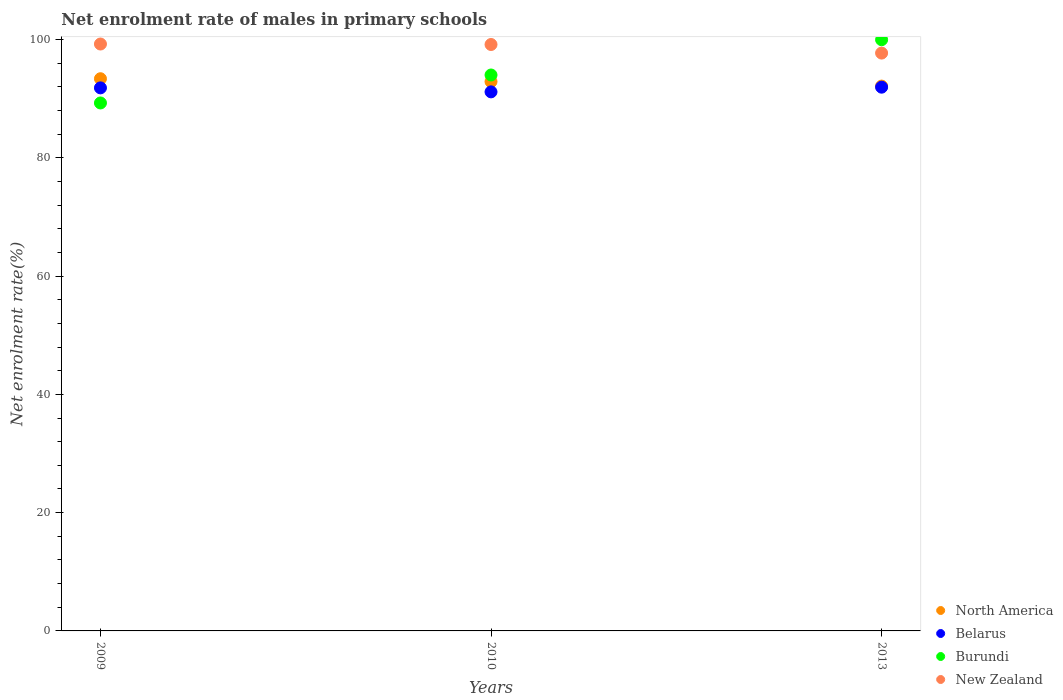How many different coloured dotlines are there?
Make the answer very short. 4. Is the number of dotlines equal to the number of legend labels?
Offer a terse response. Yes. What is the net enrolment rate of males in primary schools in North America in 2013?
Provide a short and direct response. 92.12. Across all years, what is the maximum net enrolment rate of males in primary schools in North America?
Make the answer very short. 93.36. Across all years, what is the minimum net enrolment rate of males in primary schools in Burundi?
Offer a terse response. 89.27. In which year was the net enrolment rate of males in primary schools in North America maximum?
Provide a succinct answer. 2009. In which year was the net enrolment rate of males in primary schools in New Zealand minimum?
Provide a short and direct response. 2013. What is the total net enrolment rate of males in primary schools in New Zealand in the graph?
Offer a terse response. 296.08. What is the difference between the net enrolment rate of males in primary schools in New Zealand in 2009 and that in 2010?
Provide a succinct answer. 0.08. What is the difference between the net enrolment rate of males in primary schools in Burundi in 2013 and the net enrolment rate of males in primary schools in New Zealand in 2010?
Offer a terse response. 0.81. What is the average net enrolment rate of males in primary schools in North America per year?
Provide a succinct answer. 92.78. In the year 2009, what is the difference between the net enrolment rate of males in primary schools in North America and net enrolment rate of males in primary schools in New Zealand?
Your response must be concise. -5.87. In how many years, is the net enrolment rate of males in primary schools in New Zealand greater than 56 %?
Offer a terse response. 3. What is the ratio of the net enrolment rate of males in primary schools in North America in 2009 to that in 2013?
Provide a succinct answer. 1.01. Is the net enrolment rate of males in primary schools in New Zealand in 2009 less than that in 2010?
Provide a short and direct response. No. Is the difference between the net enrolment rate of males in primary schools in North America in 2009 and 2013 greater than the difference between the net enrolment rate of males in primary schools in New Zealand in 2009 and 2013?
Offer a terse response. No. What is the difference between the highest and the second highest net enrolment rate of males in primary schools in North America?
Your response must be concise. 0.49. What is the difference between the highest and the lowest net enrolment rate of males in primary schools in Burundi?
Make the answer very short. 10.69. In how many years, is the net enrolment rate of males in primary schools in Belarus greater than the average net enrolment rate of males in primary schools in Belarus taken over all years?
Make the answer very short. 2. Is it the case that in every year, the sum of the net enrolment rate of males in primary schools in Burundi and net enrolment rate of males in primary schools in North America  is greater than the sum of net enrolment rate of males in primary schools in Belarus and net enrolment rate of males in primary schools in New Zealand?
Your answer should be very brief. No. Is it the case that in every year, the sum of the net enrolment rate of males in primary schools in Burundi and net enrolment rate of males in primary schools in Belarus  is greater than the net enrolment rate of males in primary schools in New Zealand?
Your response must be concise. Yes. How many dotlines are there?
Keep it short and to the point. 4. How many years are there in the graph?
Make the answer very short. 3. What is the difference between two consecutive major ticks on the Y-axis?
Your response must be concise. 20. Does the graph contain any zero values?
Offer a terse response. No. Does the graph contain grids?
Your answer should be compact. No. How many legend labels are there?
Keep it short and to the point. 4. What is the title of the graph?
Keep it short and to the point. Net enrolment rate of males in primary schools. What is the label or title of the Y-axis?
Offer a very short reply. Net enrolment rate(%). What is the Net enrolment rate(%) in North America in 2009?
Offer a terse response. 93.36. What is the Net enrolment rate(%) of Belarus in 2009?
Provide a succinct answer. 91.82. What is the Net enrolment rate(%) in Burundi in 2009?
Keep it short and to the point. 89.27. What is the Net enrolment rate(%) of New Zealand in 2009?
Ensure brevity in your answer.  99.23. What is the Net enrolment rate(%) of North America in 2010?
Your answer should be very brief. 92.87. What is the Net enrolment rate(%) of Belarus in 2010?
Ensure brevity in your answer.  91.14. What is the Net enrolment rate(%) in Burundi in 2010?
Offer a terse response. 93.99. What is the Net enrolment rate(%) in New Zealand in 2010?
Your answer should be compact. 99.15. What is the Net enrolment rate(%) of North America in 2013?
Your response must be concise. 92.12. What is the Net enrolment rate(%) of Belarus in 2013?
Your answer should be very brief. 91.93. What is the Net enrolment rate(%) in Burundi in 2013?
Your response must be concise. 99.96. What is the Net enrolment rate(%) of New Zealand in 2013?
Your answer should be compact. 97.7. Across all years, what is the maximum Net enrolment rate(%) of North America?
Make the answer very short. 93.36. Across all years, what is the maximum Net enrolment rate(%) of Belarus?
Ensure brevity in your answer.  91.93. Across all years, what is the maximum Net enrolment rate(%) of Burundi?
Provide a short and direct response. 99.96. Across all years, what is the maximum Net enrolment rate(%) of New Zealand?
Make the answer very short. 99.23. Across all years, what is the minimum Net enrolment rate(%) in North America?
Provide a short and direct response. 92.12. Across all years, what is the minimum Net enrolment rate(%) of Belarus?
Offer a terse response. 91.14. Across all years, what is the minimum Net enrolment rate(%) in Burundi?
Provide a succinct answer. 89.27. Across all years, what is the minimum Net enrolment rate(%) of New Zealand?
Provide a succinct answer. 97.7. What is the total Net enrolment rate(%) of North America in the graph?
Give a very brief answer. 278.35. What is the total Net enrolment rate(%) of Belarus in the graph?
Offer a terse response. 274.89. What is the total Net enrolment rate(%) in Burundi in the graph?
Offer a very short reply. 283.22. What is the total Net enrolment rate(%) of New Zealand in the graph?
Offer a very short reply. 296.08. What is the difference between the Net enrolment rate(%) in North America in 2009 and that in 2010?
Give a very brief answer. 0.49. What is the difference between the Net enrolment rate(%) of Belarus in 2009 and that in 2010?
Keep it short and to the point. 0.68. What is the difference between the Net enrolment rate(%) in Burundi in 2009 and that in 2010?
Offer a very short reply. -4.73. What is the difference between the Net enrolment rate(%) in New Zealand in 2009 and that in 2010?
Offer a terse response. 0.08. What is the difference between the Net enrolment rate(%) in North America in 2009 and that in 2013?
Your answer should be compact. 1.25. What is the difference between the Net enrolment rate(%) in Belarus in 2009 and that in 2013?
Ensure brevity in your answer.  -0.12. What is the difference between the Net enrolment rate(%) of Burundi in 2009 and that in 2013?
Your answer should be very brief. -10.69. What is the difference between the Net enrolment rate(%) in New Zealand in 2009 and that in 2013?
Your response must be concise. 1.53. What is the difference between the Net enrolment rate(%) of North America in 2010 and that in 2013?
Keep it short and to the point. 0.76. What is the difference between the Net enrolment rate(%) in Belarus in 2010 and that in 2013?
Your response must be concise. -0.79. What is the difference between the Net enrolment rate(%) of Burundi in 2010 and that in 2013?
Your answer should be compact. -5.96. What is the difference between the Net enrolment rate(%) in New Zealand in 2010 and that in 2013?
Make the answer very short. 1.45. What is the difference between the Net enrolment rate(%) of North America in 2009 and the Net enrolment rate(%) of Belarus in 2010?
Provide a short and direct response. 2.22. What is the difference between the Net enrolment rate(%) in North America in 2009 and the Net enrolment rate(%) in Burundi in 2010?
Your answer should be very brief. -0.63. What is the difference between the Net enrolment rate(%) of North America in 2009 and the Net enrolment rate(%) of New Zealand in 2010?
Your response must be concise. -5.79. What is the difference between the Net enrolment rate(%) in Belarus in 2009 and the Net enrolment rate(%) in Burundi in 2010?
Your answer should be compact. -2.18. What is the difference between the Net enrolment rate(%) of Belarus in 2009 and the Net enrolment rate(%) of New Zealand in 2010?
Your answer should be compact. -7.33. What is the difference between the Net enrolment rate(%) of Burundi in 2009 and the Net enrolment rate(%) of New Zealand in 2010?
Provide a succinct answer. -9.88. What is the difference between the Net enrolment rate(%) in North America in 2009 and the Net enrolment rate(%) in Belarus in 2013?
Make the answer very short. 1.43. What is the difference between the Net enrolment rate(%) in North America in 2009 and the Net enrolment rate(%) in Burundi in 2013?
Make the answer very short. -6.59. What is the difference between the Net enrolment rate(%) of North America in 2009 and the Net enrolment rate(%) of New Zealand in 2013?
Provide a short and direct response. -4.34. What is the difference between the Net enrolment rate(%) of Belarus in 2009 and the Net enrolment rate(%) of Burundi in 2013?
Your answer should be very brief. -8.14. What is the difference between the Net enrolment rate(%) in Belarus in 2009 and the Net enrolment rate(%) in New Zealand in 2013?
Keep it short and to the point. -5.88. What is the difference between the Net enrolment rate(%) in Burundi in 2009 and the Net enrolment rate(%) in New Zealand in 2013?
Provide a succinct answer. -8.43. What is the difference between the Net enrolment rate(%) in North America in 2010 and the Net enrolment rate(%) in Belarus in 2013?
Provide a short and direct response. 0.94. What is the difference between the Net enrolment rate(%) of North America in 2010 and the Net enrolment rate(%) of Burundi in 2013?
Ensure brevity in your answer.  -7.08. What is the difference between the Net enrolment rate(%) in North America in 2010 and the Net enrolment rate(%) in New Zealand in 2013?
Your answer should be very brief. -4.83. What is the difference between the Net enrolment rate(%) of Belarus in 2010 and the Net enrolment rate(%) of Burundi in 2013?
Provide a succinct answer. -8.81. What is the difference between the Net enrolment rate(%) of Belarus in 2010 and the Net enrolment rate(%) of New Zealand in 2013?
Your answer should be compact. -6.56. What is the difference between the Net enrolment rate(%) of Burundi in 2010 and the Net enrolment rate(%) of New Zealand in 2013?
Your answer should be very brief. -3.71. What is the average Net enrolment rate(%) in North America per year?
Make the answer very short. 92.78. What is the average Net enrolment rate(%) of Belarus per year?
Your answer should be very brief. 91.63. What is the average Net enrolment rate(%) of Burundi per year?
Keep it short and to the point. 94.41. What is the average Net enrolment rate(%) in New Zealand per year?
Your answer should be compact. 98.69. In the year 2009, what is the difference between the Net enrolment rate(%) of North America and Net enrolment rate(%) of Belarus?
Provide a short and direct response. 1.55. In the year 2009, what is the difference between the Net enrolment rate(%) of North America and Net enrolment rate(%) of Burundi?
Ensure brevity in your answer.  4.1. In the year 2009, what is the difference between the Net enrolment rate(%) in North America and Net enrolment rate(%) in New Zealand?
Give a very brief answer. -5.87. In the year 2009, what is the difference between the Net enrolment rate(%) in Belarus and Net enrolment rate(%) in Burundi?
Keep it short and to the point. 2.55. In the year 2009, what is the difference between the Net enrolment rate(%) of Belarus and Net enrolment rate(%) of New Zealand?
Make the answer very short. -7.41. In the year 2009, what is the difference between the Net enrolment rate(%) in Burundi and Net enrolment rate(%) in New Zealand?
Ensure brevity in your answer.  -9.97. In the year 2010, what is the difference between the Net enrolment rate(%) in North America and Net enrolment rate(%) in Belarus?
Provide a short and direct response. 1.73. In the year 2010, what is the difference between the Net enrolment rate(%) of North America and Net enrolment rate(%) of Burundi?
Keep it short and to the point. -1.12. In the year 2010, what is the difference between the Net enrolment rate(%) in North America and Net enrolment rate(%) in New Zealand?
Your answer should be very brief. -6.28. In the year 2010, what is the difference between the Net enrolment rate(%) of Belarus and Net enrolment rate(%) of Burundi?
Make the answer very short. -2.85. In the year 2010, what is the difference between the Net enrolment rate(%) in Belarus and Net enrolment rate(%) in New Zealand?
Provide a succinct answer. -8.01. In the year 2010, what is the difference between the Net enrolment rate(%) of Burundi and Net enrolment rate(%) of New Zealand?
Make the answer very short. -5.15. In the year 2013, what is the difference between the Net enrolment rate(%) in North America and Net enrolment rate(%) in Belarus?
Your answer should be very brief. 0.18. In the year 2013, what is the difference between the Net enrolment rate(%) in North America and Net enrolment rate(%) in Burundi?
Provide a succinct answer. -7.84. In the year 2013, what is the difference between the Net enrolment rate(%) in North America and Net enrolment rate(%) in New Zealand?
Your answer should be compact. -5.58. In the year 2013, what is the difference between the Net enrolment rate(%) of Belarus and Net enrolment rate(%) of Burundi?
Provide a short and direct response. -8.02. In the year 2013, what is the difference between the Net enrolment rate(%) in Belarus and Net enrolment rate(%) in New Zealand?
Your response must be concise. -5.77. In the year 2013, what is the difference between the Net enrolment rate(%) of Burundi and Net enrolment rate(%) of New Zealand?
Give a very brief answer. 2.26. What is the ratio of the Net enrolment rate(%) of North America in 2009 to that in 2010?
Ensure brevity in your answer.  1.01. What is the ratio of the Net enrolment rate(%) of Belarus in 2009 to that in 2010?
Make the answer very short. 1.01. What is the ratio of the Net enrolment rate(%) of Burundi in 2009 to that in 2010?
Provide a succinct answer. 0.95. What is the ratio of the Net enrolment rate(%) in North America in 2009 to that in 2013?
Offer a terse response. 1.01. What is the ratio of the Net enrolment rate(%) in Belarus in 2009 to that in 2013?
Your answer should be compact. 1. What is the ratio of the Net enrolment rate(%) in Burundi in 2009 to that in 2013?
Ensure brevity in your answer.  0.89. What is the ratio of the Net enrolment rate(%) of New Zealand in 2009 to that in 2013?
Give a very brief answer. 1.02. What is the ratio of the Net enrolment rate(%) of North America in 2010 to that in 2013?
Ensure brevity in your answer.  1.01. What is the ratio of the Net enrolment rate(%) of Burundi in 2010 to that in 2013?
Offer a terse response. 0.94. What is the ratio of the Net enrolment rate(%) of New Zealand in 2010 to that in 2013?
Offer a very short reply. 1.01. What is the difference between the highest and the second highest Net enrolment rate(%) in North America?
Your response must be concise. 0.49. What is the difference between the highest and the second highest Net enrolment rate(%) in Belarus?
Offer a terse response. 0.12. What is the difference between the highest and the second highest Net enrolment rate(%) in Burundi?
Provide a short and direct response. 5.96. What is the difference between the highest and the second highest Net enrolment rate(%) of New Zealand?
Make the answer very short. 0.08. What is the difference between the highest and the lowest Net enrolment rate(%) of North America?
Your answer should be very brief. 1.25. What is the difference between the highest and the lowest Net enrolment rate(%) of Belarus?
Provide a short and direct response. 0.79. What is the difference between the highest and the lowest Net enrolment rate(%) of Burundi?
Offer a terse response. 10.69. What is the difference between the highest and the lowest Net enrolment rate(%) of New Zealand?
Give a very brief answer. 1.53. 